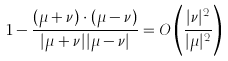<formula> <loc_0><loc_0><loc_500><loc_500>1 - \frac { ( \mu + \nu ) \cdot ( \mu - \nu ) } { | \mu + \nu | | \mu - \nu | } = O \left ( \frac { | \nu | ^ { 2 } } { | \mu | ^ { 2 } } \right )</formula> 